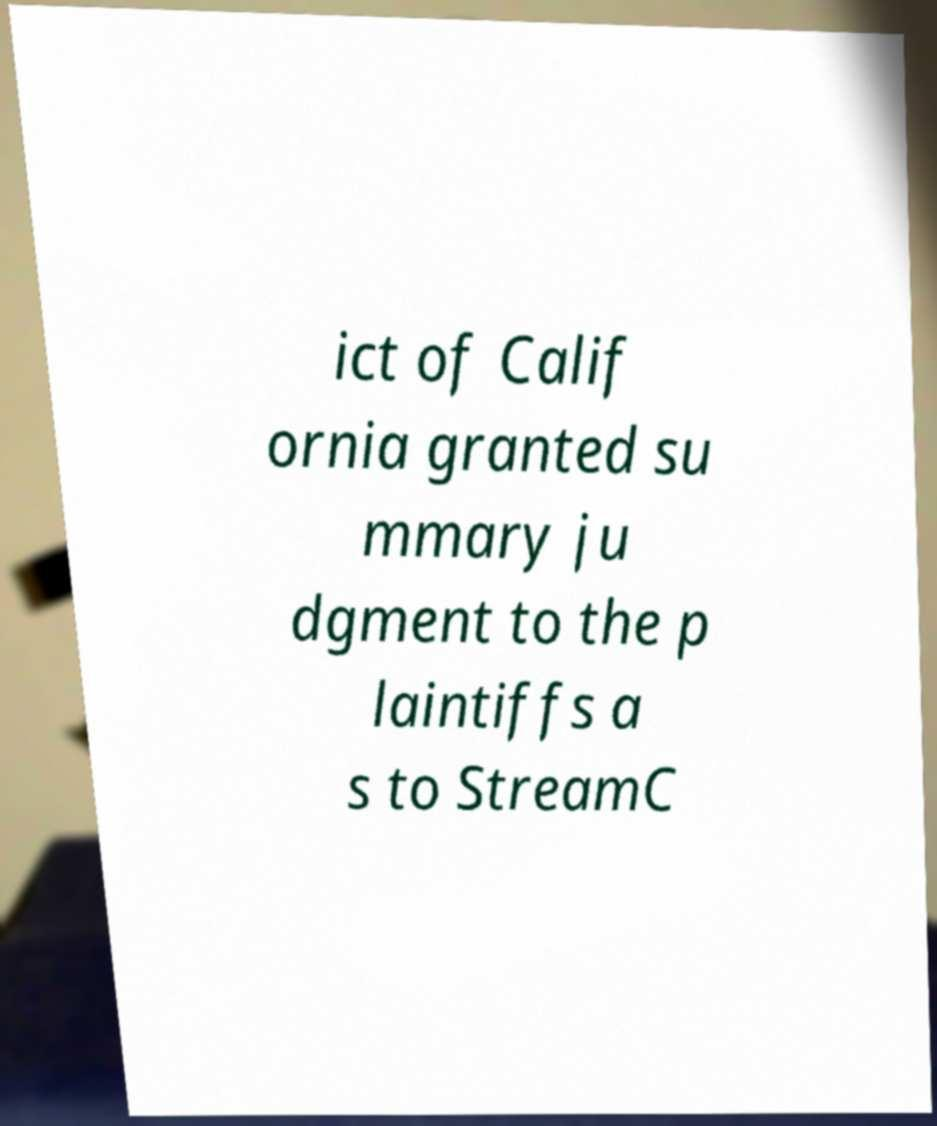There's text embedded in this image that I need extracted. Can you transcribe it verbatim? ict of Calif ornia granted su mmary ju dgment to the p laintiffs a s to StreamC 